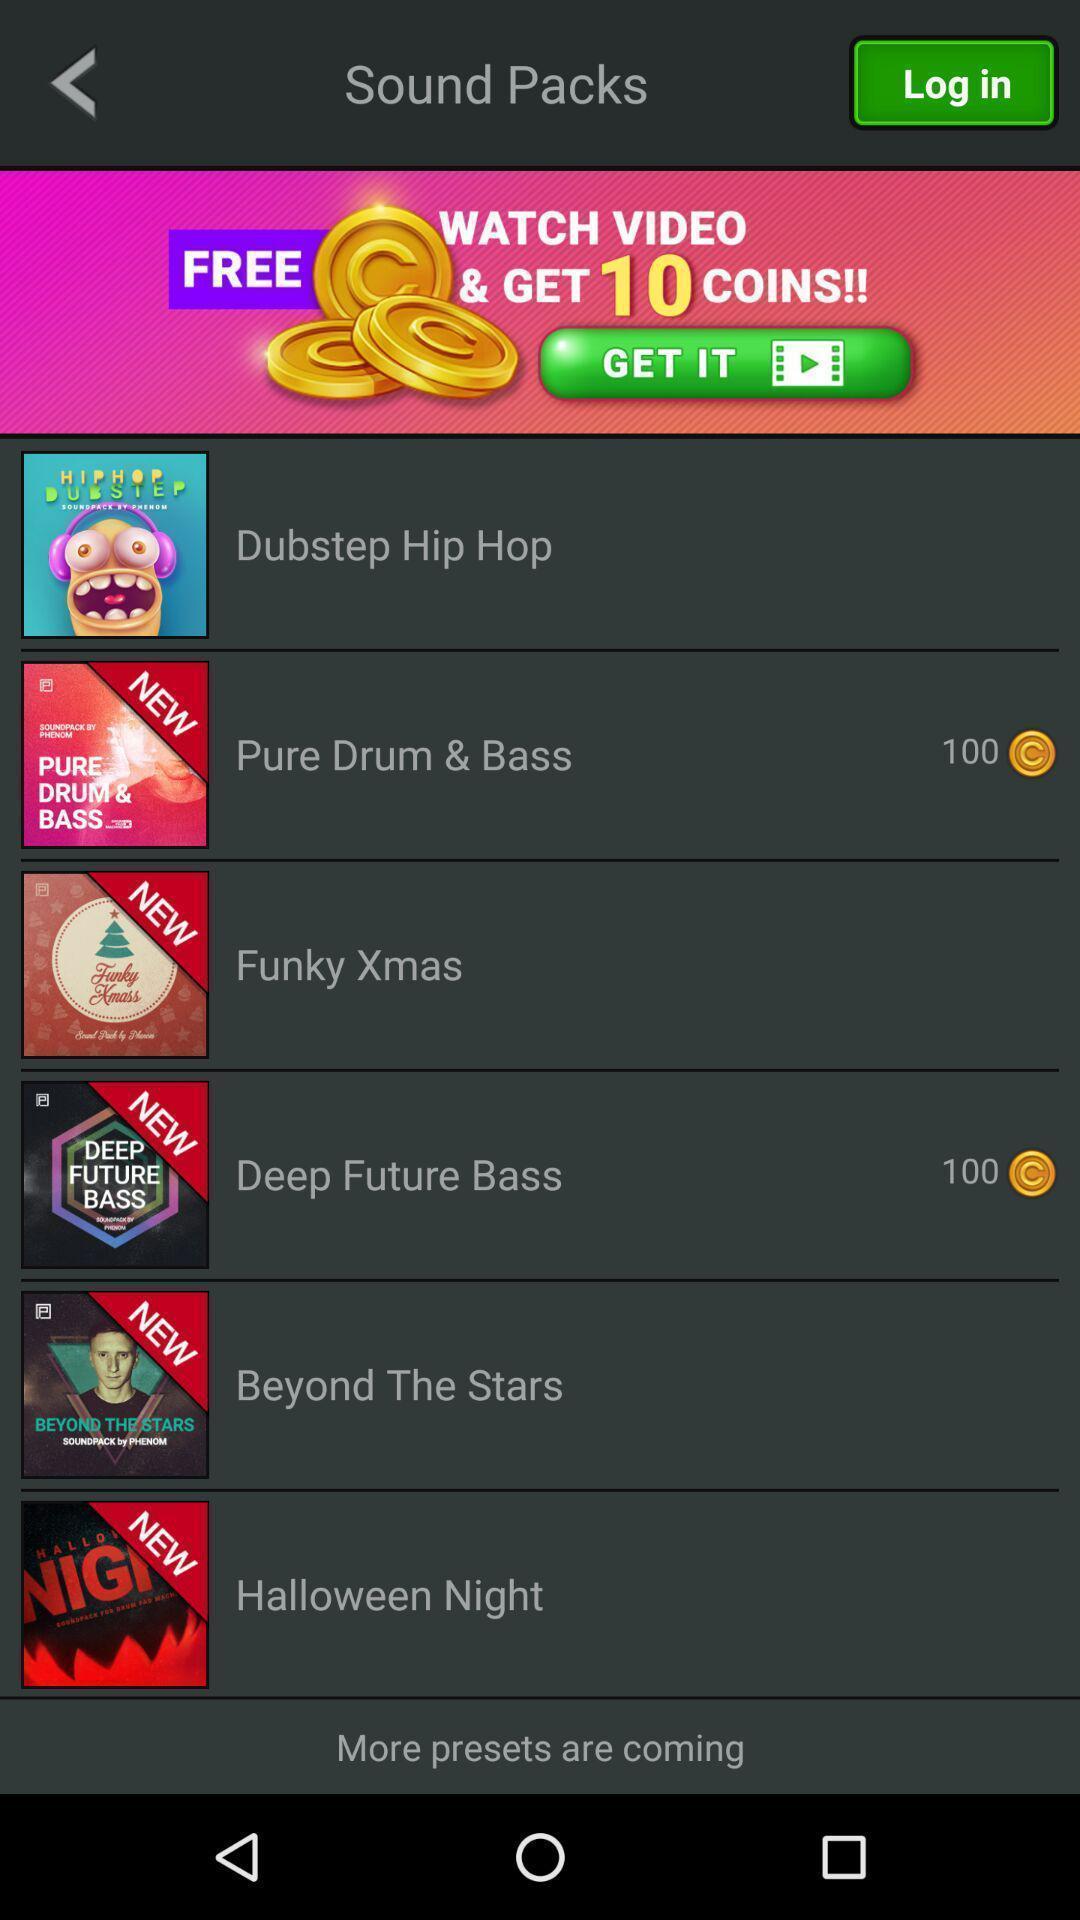Please provide a description for this image. Screen displaying the list of options in a music page. 